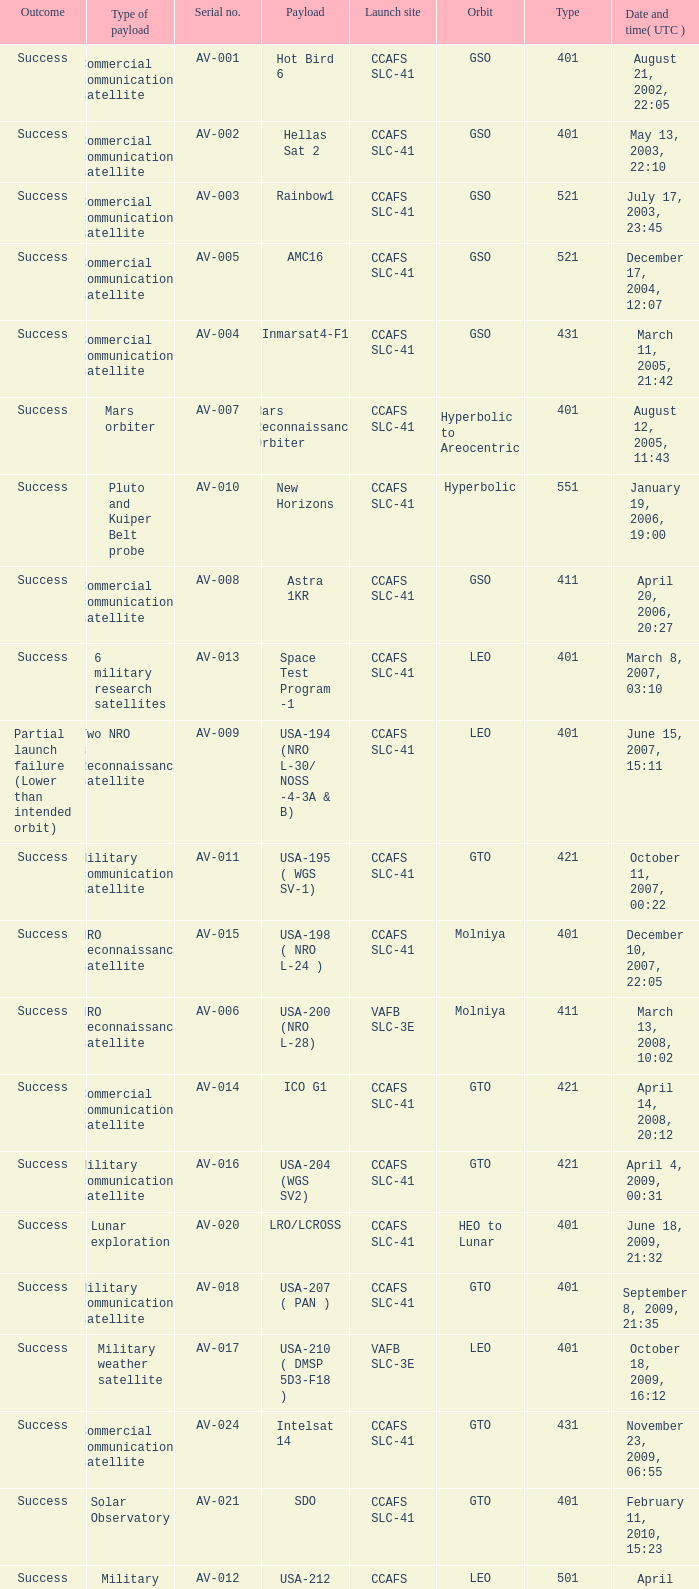What payload was on November 26, 2011, 15:02? Mars rover. 